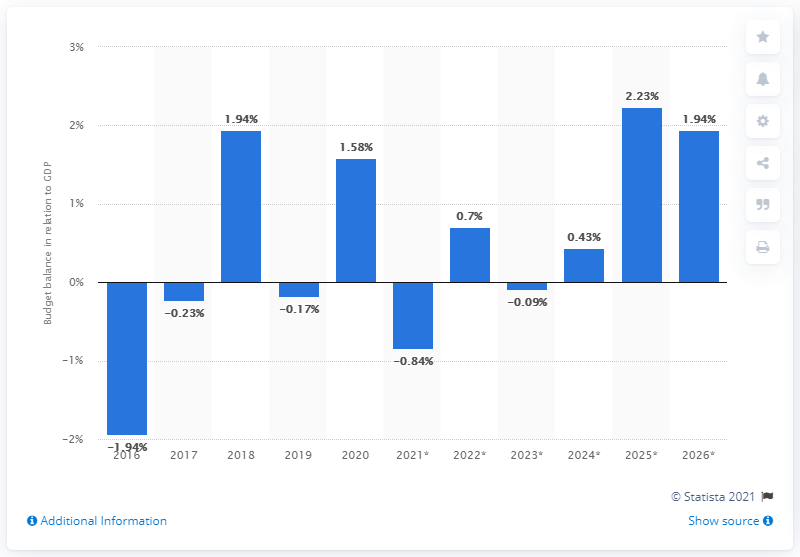List a handful of essential elements in this visual. According to the provided information, Chad's budget surplus in 2020 was 1.58% of the country's Gross Domestic Product (GDP). The budget balance of Chad in relation to GDP was shown by statistics in 2020. 